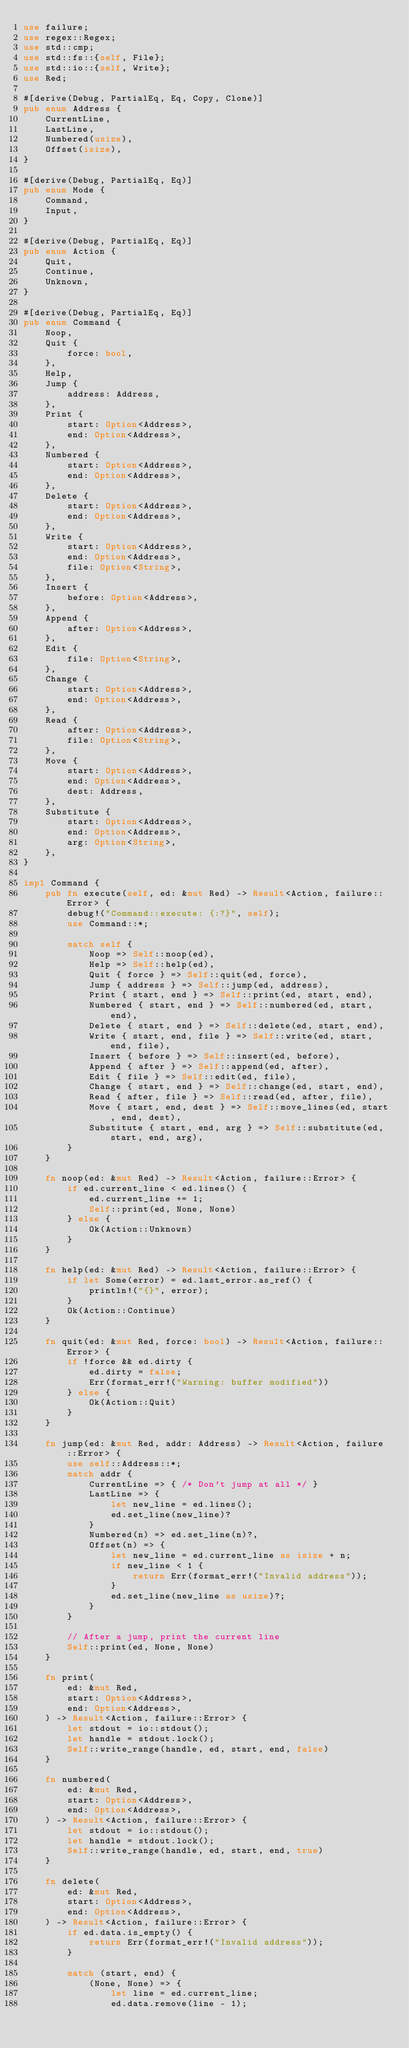Convert code to text. <code><loc_0><loc_0><loc_500><loc_500><_Rust_>use failure;
use regex::Regex;
use std::cmp;
use std::fs::{self, File};
use std::io::{self, Write};
use Red;

#[derive(Debug, PartialEq, Eq, Copy, Clone)]
pub enum Address {
    CurrentLine,
    LastLine,
    Numbered(usize),
    Offset(isize),
}

#[derive(Debug, PartialEq, Eq)]
pub enum Mode {
    Command,
    Input,
}

#[derive(Debug, PartialEq, Eq)]
pub enum Action {
    Quit,
    Continue,
    Unknown,
}

#[derive(Debug, PartialEq, Eq)]
pub enum Command {
    Noop,
    Quit {
        force: bool,
    },
    Help,
    Jump {
        address: Address,
    },
    Print {
        start: Option<Address>,
        end: Option<Address>,
    },
    Numbered {
        start: Option<Address>,
        end: Option<Address>,
    },
    Delete {
        start: Option<Address>,
        end: Option<Address>,
    },
    Write {
        start: Option<Address>,
        end: Option<Address>,
        file: Option<String>,
    },
    Insert {
        before: Option<Address>,
    },
    Append {
        after: Option<Address>,
    },
    Edit {
        file: Option<String>,
    },
    Change {
        start: Option<Address>,
        end: Option<Address>,
    },
    Read {
        after: Option<Address>,
        file: Option<String>,
    },
    Move {
        start: Option<Address>,
        end: Option<Address>,
        dest: Address,
    },
    Substitute {
        start: Option<Address>,
        end: Option<Address>,
        arg: Option<String>,
    },
}

impl Command {
    pub fn execute(self, ed: &mut Red) -> Result<Action, failure::Error> {
        debug!("Command::execute: {:?}", self);
        use Command::*;

        match self {
            Noop => Self::noop(ed),
            Help => Self::help(ed),
            Quit { force } => Self::quit(ed, force),
            Jump { address } => Self::jump(ed, address),
            Print { start, end } => Self::print(ed, start, end),
            Numbered { start, end } => Self::numbered(ed, start, end),
            Delete { start, end } => Self::delete(ed, start, end),
            Write { start, end, file } => Self::write(ed, start, end, file),
            Insert { before } => Self::insert(ed, before),
            Append { after } => Self::append(ed, after),
            Edit { file } => Self::edit(ed, file),
            Change { start, end } => Self::change(ed, start, end),
            Read { after, file } => Self::read(ed, after, file),
            Move { start, end, dest } => Self::move_lines(ed, start, end, dest),
            Substitute { start, end, arg } => Self::substitute(ed, start, end, arg),
        }
    }

    fn noop(ed: &mut Red) -> Result<Action, failure::Error> {
        if ed.current_line < ed.lines() {
            ed.current_line += 1;
            Self::print(ed, None, None)
        } else {
            Ok(Action::Unknown)
        }
    }

    fn help(ed: &mut Red) -> Result<Action, failure::Error> {
        if let Some(error) = ed.last_error.as_ref() {
            println!("{}", error);
        }
        Ok(Action::Continue)
    }

    fn quit(ed: &mut Red, force: bool) -> Result<Action, failure::Error> {
        if !force && ed.dirty {
            ed.dirty = false;
            Err(format_err!("Warning: buffer modified"))
        } else {
            Ok(Action::Quit)
        }
    }

    fn jump(ed: &mut Red, addr: Address) -> Result<Action, failure::Error> {
        use self::Address::*;
        match addr {
            CurrentLine => { /* Don't jump at all */ }
            LastLine => {
                let new_line = ed.lines();
                ed.set_line(new_line)?
            }
            Numbered(n) => ed.set_line(n)?,
            Offset(n) => {
                let new_line = ed.current_line as isize + n;
                if new_line < 1 {
                    return Err(format_err!("Invalid address"));
                }
                ed.set_line(new_line as usize)?;
            }
        }

        // After a jump, print the current line
        Self::print(ed, None, None)
    }

    fn print(
        ed: &mut Red,
        start: Option<Address>,
        end: Option<Address>,
    ) -> Result<Action, failure::Error> {
        let stdout = io::stdout();
        let handle = stdout.lock();
        Self::write_range(handle, ed, start, end, false)
    }

    fn numbered(
        ed: &mut Red,
        start: Option<Address>,
        end: Option<Address>,
    ) -> Result<Action, failure::Error> {
        let stdout = io::stdout();
        let handle = stdout.lock();
        Self::write_range(handle, ed, start, end, true)
    }

    fn delete(
        ed: &mut Red,
        start: Option<Address>,
        end: Option<Address>,
    ) -> Result<Action, failure::Error> {
        if ed.data.is_empty() {
            return Err(format_err!("Invalid address"));
        }

        match (start, end) {
            (None, None) => {
                let line = ed.current_line;
                ed.data.remove(line - 1);</code> 